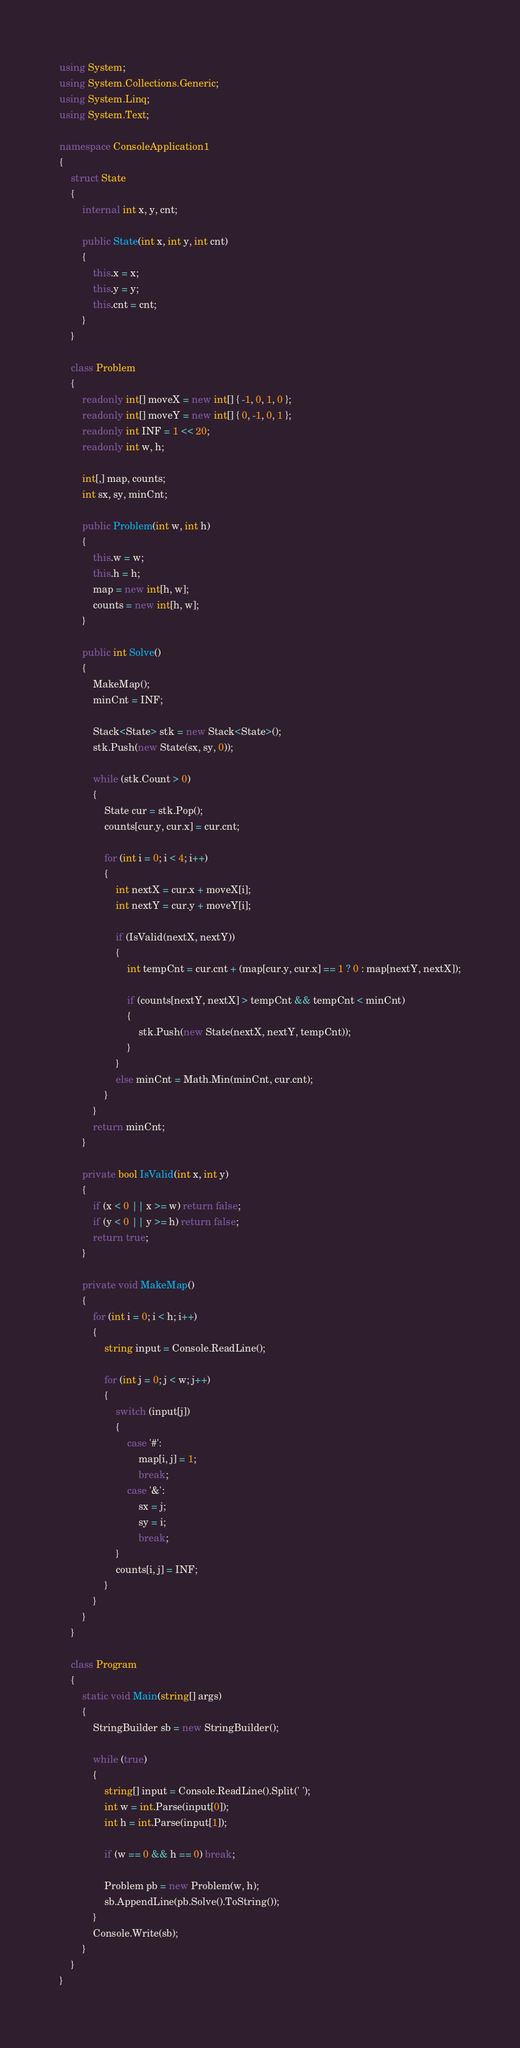<code> <loc_0><loc_0><loc_500><loc_500><_C#_>using System;
using System.Collections.Generic;
using System.Linq;
using System.Text;

namespace ConsoleApplication1
{
    struct State
    {
        internal int x, y, cnt;

        public State(int x, int y, int cnt)
        {
            this.x = x;
            this.y = y;
            this.cnt = cnt;
        }
    }

    class Problem
    {
        readonly int[] moveX = new int[] { -1, 0, 1, 0 };
        readonly int[] moveY = new int[] { 0, -1, 0, 1 };
        readonly int INF = 1 << 20;
        readonly int w, h;

        int[,] map, counts;
        int sx, sy, minCnt;

        public Problem(int w, int h)
        {
            this.w = w;
            this.h = h;
            map = new int[h, w];
            counts = new int[h, w];
        }

        public int Solve()
        {
            MakeMap();
            minCnt = INF;

            Stack<State> stk = new Stack<State>();
            stk.Push(new State(sx, sy, 0));

            while (stk.Count > 0)
            {
                State cur = stk.Pop();
                counts[cur.y, cur.x] = cur.cnt;

                for (int i = 0; i < 4; i++)
                {
                    int nextX = cur.x + moveX[i];
                    int nextY = cur.y + moveY[i];

                    if (IsValid(nextX, nextY))
                    {
                        int tempCnt = cur.cnt + (map[cur.y, cur.x] == 1 ? 0 : map[nextY, nextX]);

                        if (counts[nextY, nextX] > tempCnt && tempCnt < minCnt)
                        {
                            stk.Push(new State(nextX, nextY, tempCnt));
                        }
                    }
                    else minCnt = Math.Min(minCnt, cur.cnt);
                }
            }
            return minCnt;
        }

        private bool IsValid(int x, int y)
        {
            if (x < 0 || x >= w) return false;
            if (y < 0 || y >= h) return false;
            return true;
        }

        private void MakeMap()
        {
            for (int i = 0; i < h; i++)
            {
                string input = Console.ReadLine();

                for (int j = 0; j < w; j++)
                {
                    switch (input[j])
                    {
                        case '#':
                            map[i, j] = 1;
                            break;
                        case '&':
                            sx = j;
                            sy = i;
                            break;
                    }
                    counts[i, j] = INF;
                }
            }
        }
    }

    class Program
    {
        static void Main(string[] args)
        {
            StringBuilder sb = new StringBuilder();

            while (true)
            {
                string[] input = Console.ReadLine().Split(' ');
                int w = int.Parse(input[0]);
                int h = int.Parse(input[1]);

                if (w == 0 && h == 0) break;

                Problem pb = new Problem(w, h);
                sb.AppendLine(pb.Solve().ToString());
            }
            Console.Write(sb);
        }
    }
}</code> 